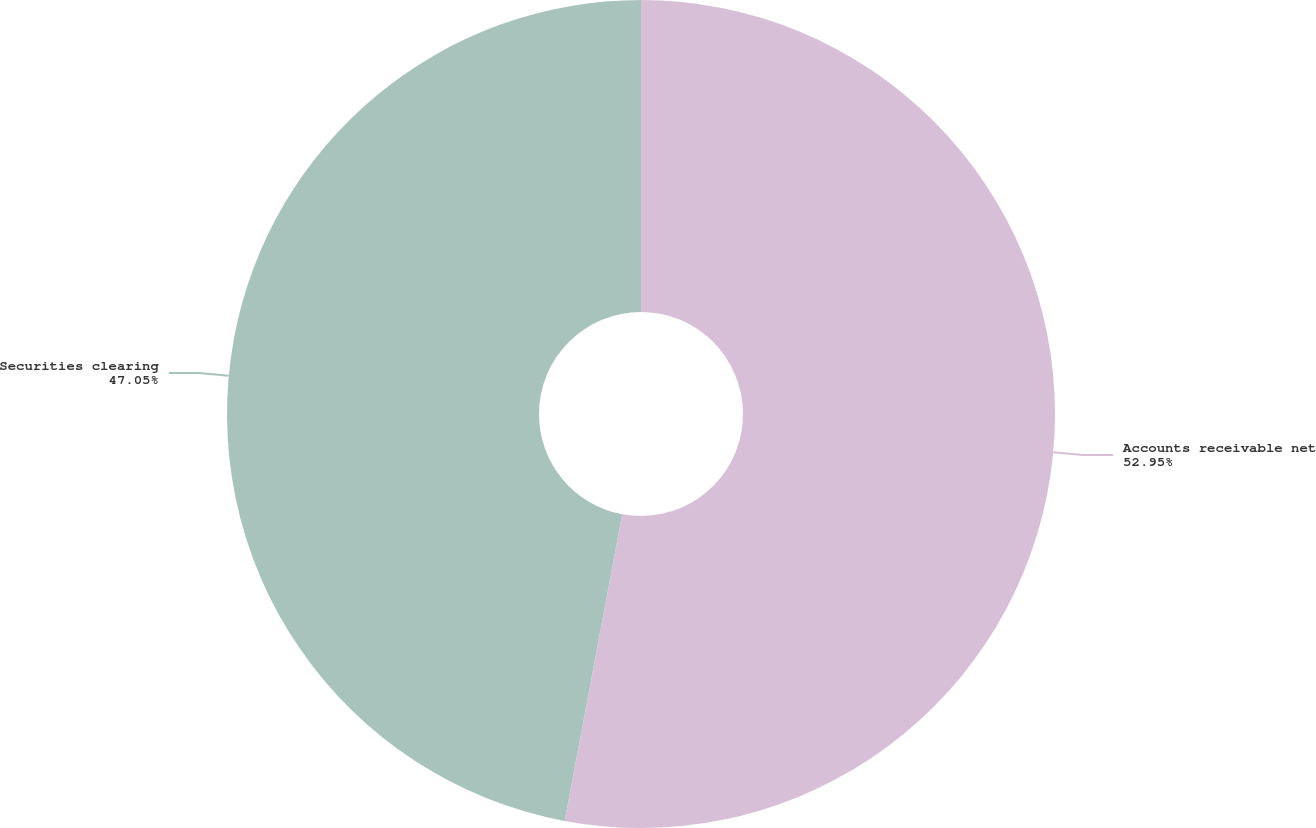Convert chart to OTSL. <chart><loc_0><loc_0><loc_500><loc_500><pie_chart><fcel>Accounts receivable net<fcel>Securities clearing<nl><fcel>52.95%<fcel>47.05%<nl></chart> 